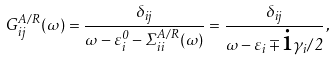Convert formula to latex. <formula><loc_0><loc_0><loc_500><loc_500>G ^ { A / R } _ { i j } ( \omega ) = \frac { \delta _ { i j } } { \omega - \varepsilon ^ { 0 } _ { i } - \Sigma ^ { A / R } _ { i i } ( \omega ) } = \frac { \delta _ { i j } } { \omega - \varepsilon _ { i } \mp \text {i} \gamma _ { i } / 2 } \, ,</formula> 